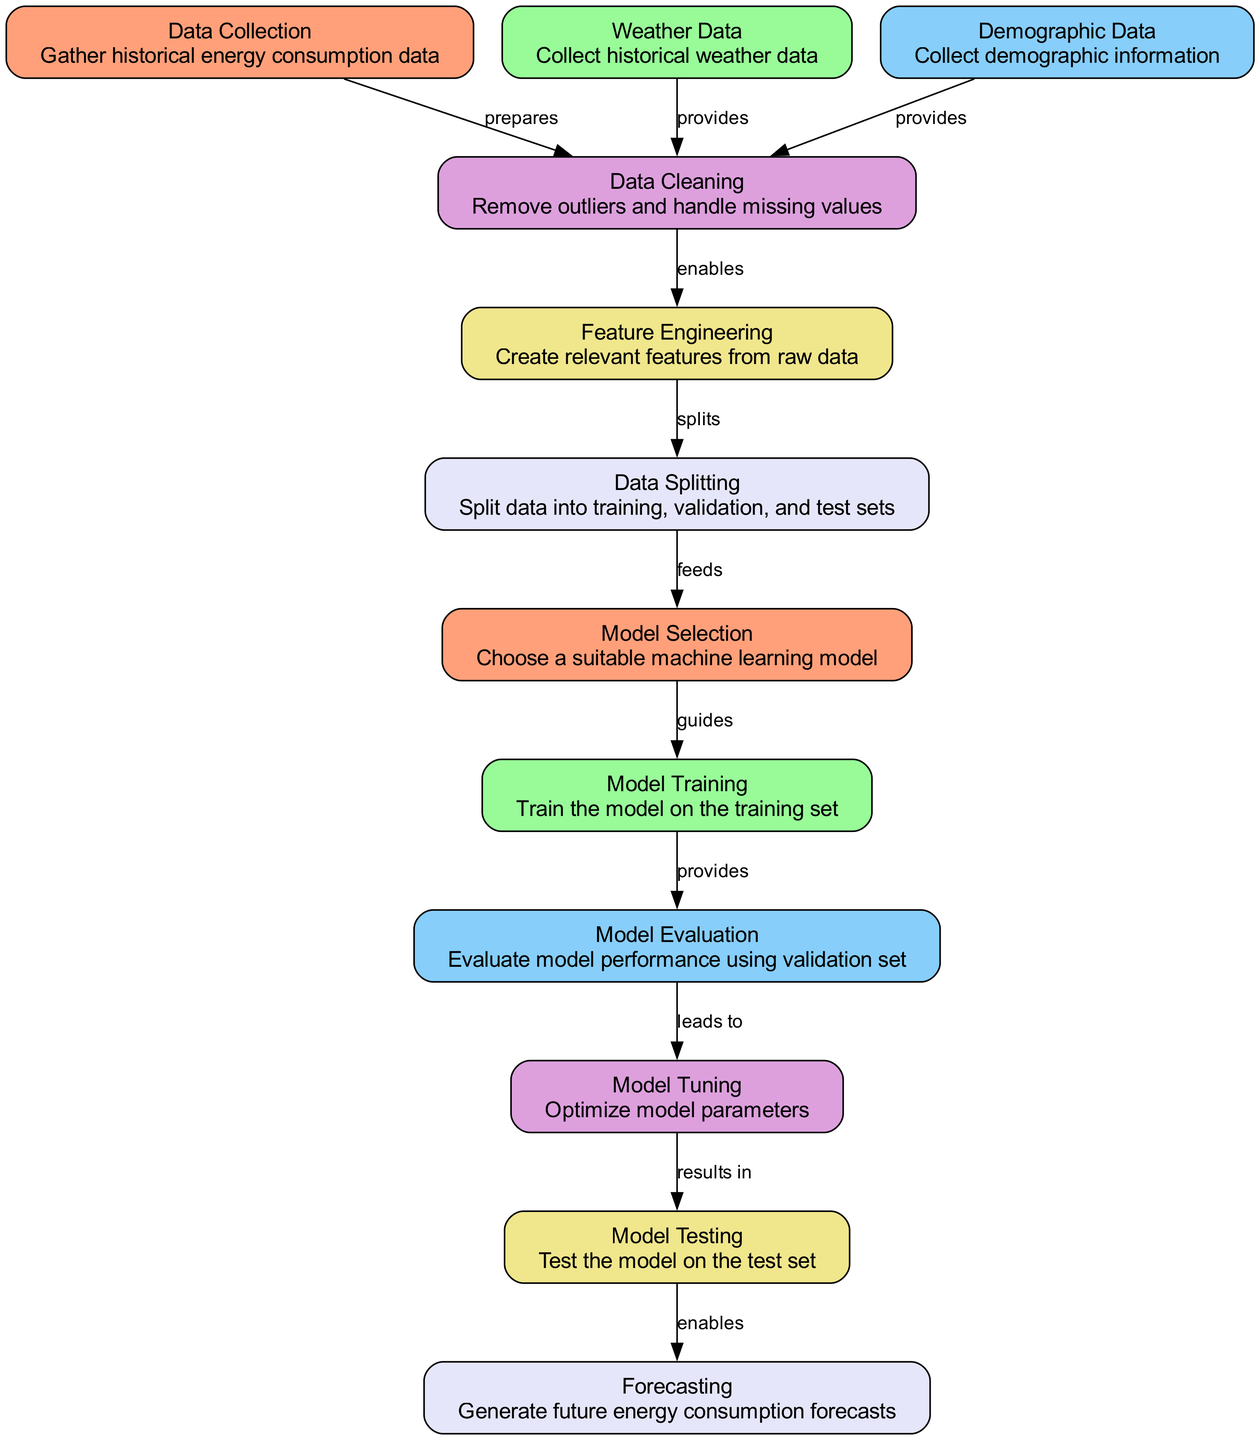What is the first node in the diagram? The first node is "Data Collection", which is the initial step in the process of forecasting household energy consumption. It is labeled as node "1".
Answer: Data Collection How many nodes are present in the diagram? To find the number of nodes, we can count the entries in the provided 'nodes' list, which contains twelve entries.
Answer: 12 What process follows "Data Cleaning"? The node that directly follows "Data Cleaning" is "Feature Engineering", indicating the subsequent step in the workflow.
Answer: Feature Engineering Which type of data is collected in the second node? The second node is labeled "Weather Data", which signifies that historical weather data is collected as part of the forecasting process.
Answer: Weather Data What is the relationship direction between "Model Evaluation" and "Model Tuning"? The edge between "Model Evaluation" and "Model Tuning" indicates that Model Evaluation leads to Model Tuning, showing how the evaluation influences the tuning process.
Answer: leads to Why is "Model Testing" important in the diagram? "Model Testing" is a necessary step that follows model tuning to validate the model on new, unseen data, ensuring that it performs well.
Answer: Validates model performance What enables the "Forecasting" step? The step "Forecasting" is enabled directly by the "Model Testing" process, indicating that it relies on the results of the test phase to generate forecasts.
Answer: Model Testing What is the last node in the workflow? The last node is "Forecasting", which is the final outcome of the entire machine learning process depicted in the diagram.
Answer: Forecasting What is the main purpose of "Feature Engineering" in this context? "Feature Engineering" involves creating relevant features from raw data, which is crucial for enhancing the model's ability to make accurate predictions.
Answer: Create relevant features 